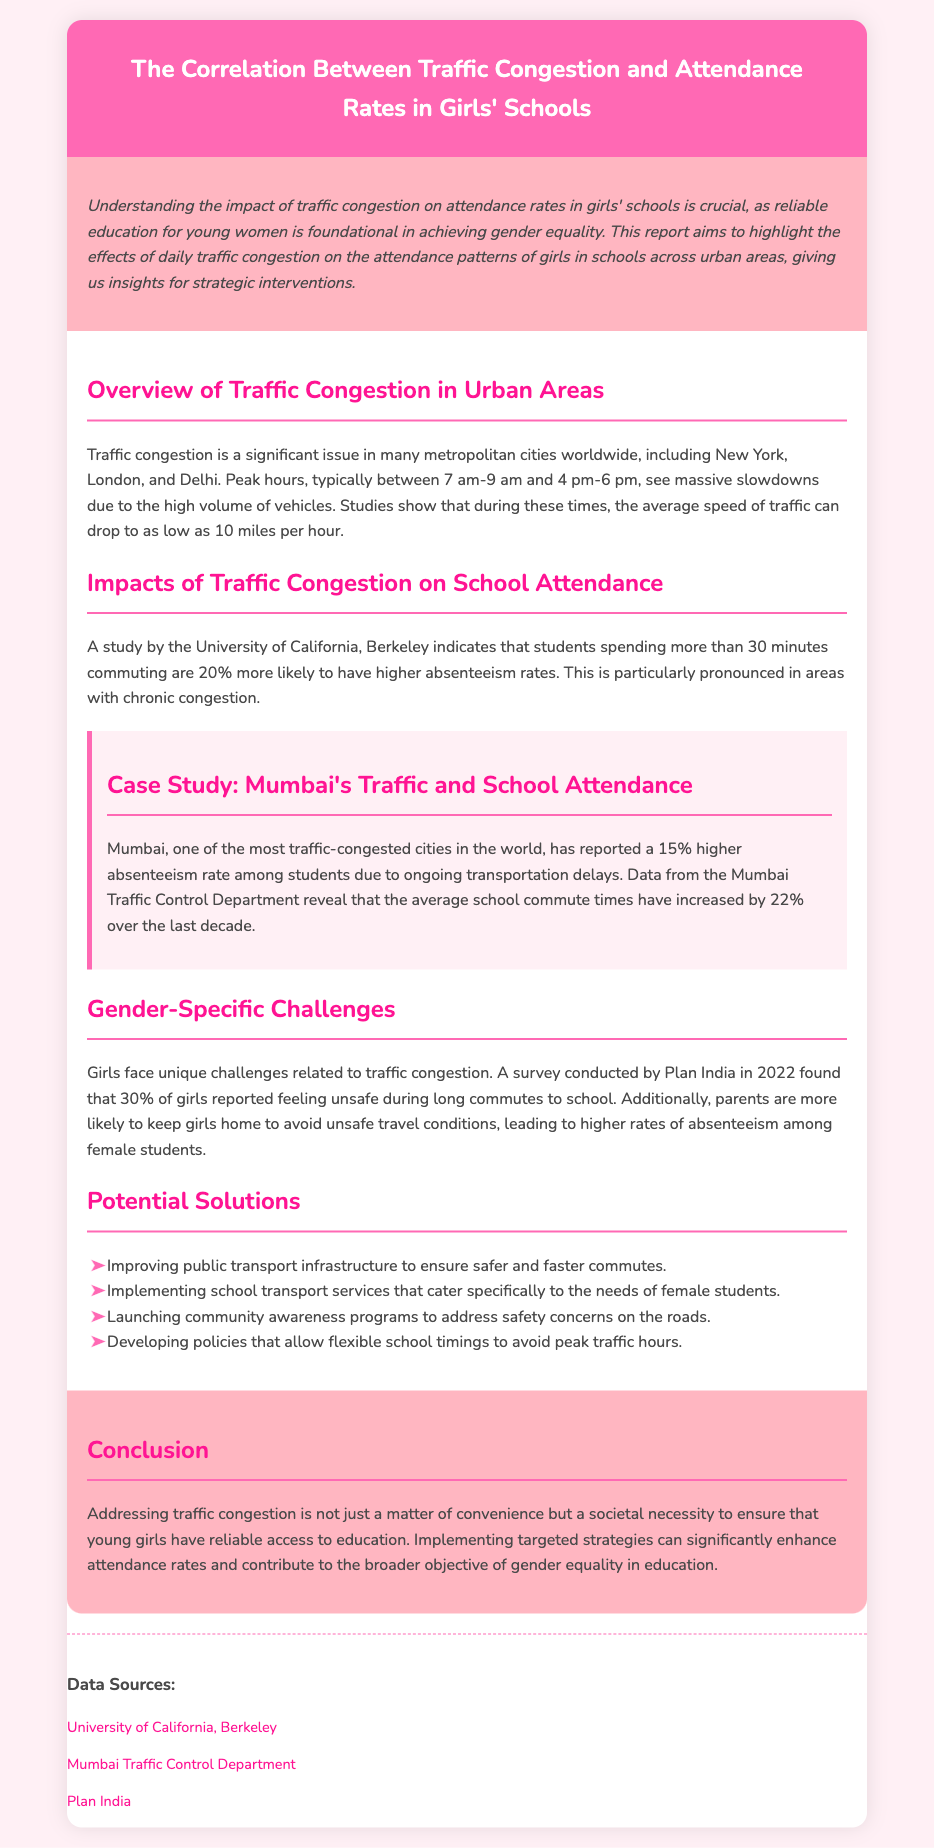What is the title of the report? The title of the report is presented in the header of the document, which specifically states the focus of the study.
Answer: The Correlation Between Traffic Congestion and Attendance Rates in Girls' Schools What percentage of girls reported feeling unsafe during long commutes? A survey conducted in 2022 provides specific statistics about girls' experiences with commuting, particularly highlighting safety concerns.
Answer: 30% What is the average speed of traffic during peak hours according to the document? The document mentions that traffic speeds drop significantly during peak hours, providing a specific figure for reference.
Answer: 10 miles per hour What city is highlighted in the case study? The case study section of the report specifically focuses on one metropolitan area to illustrate key findings.
Answer: Mumbai How much has the average school commute time increased in Mumbai over the last decade? The report includes specific data from a local traffic department showing the increase in commute times for students.
Answer: 22% What are two proposed solutions in the report? The document lists several strategic interventions aimed at reducing the impact of traffic congestion on school attendance, of which any two can be highlighted.
Answer: Improving public transport infrastructure, Implementing school transport services What effect does commuting more than 30 minutes have on absenteeism rates? A study referenced in the report discusses a correlation between longer commute times and absenteeism, specifying the likelihood of increased rates.
Answer: 20% more likely What is the unique challenge faced by girls in relation to traffic congestion mentioned in the report? The report highlights a specific concern related to gender in the context of traffic challenges affecting girls' school attendance.
Answer: Feeling unsafe during commutes 